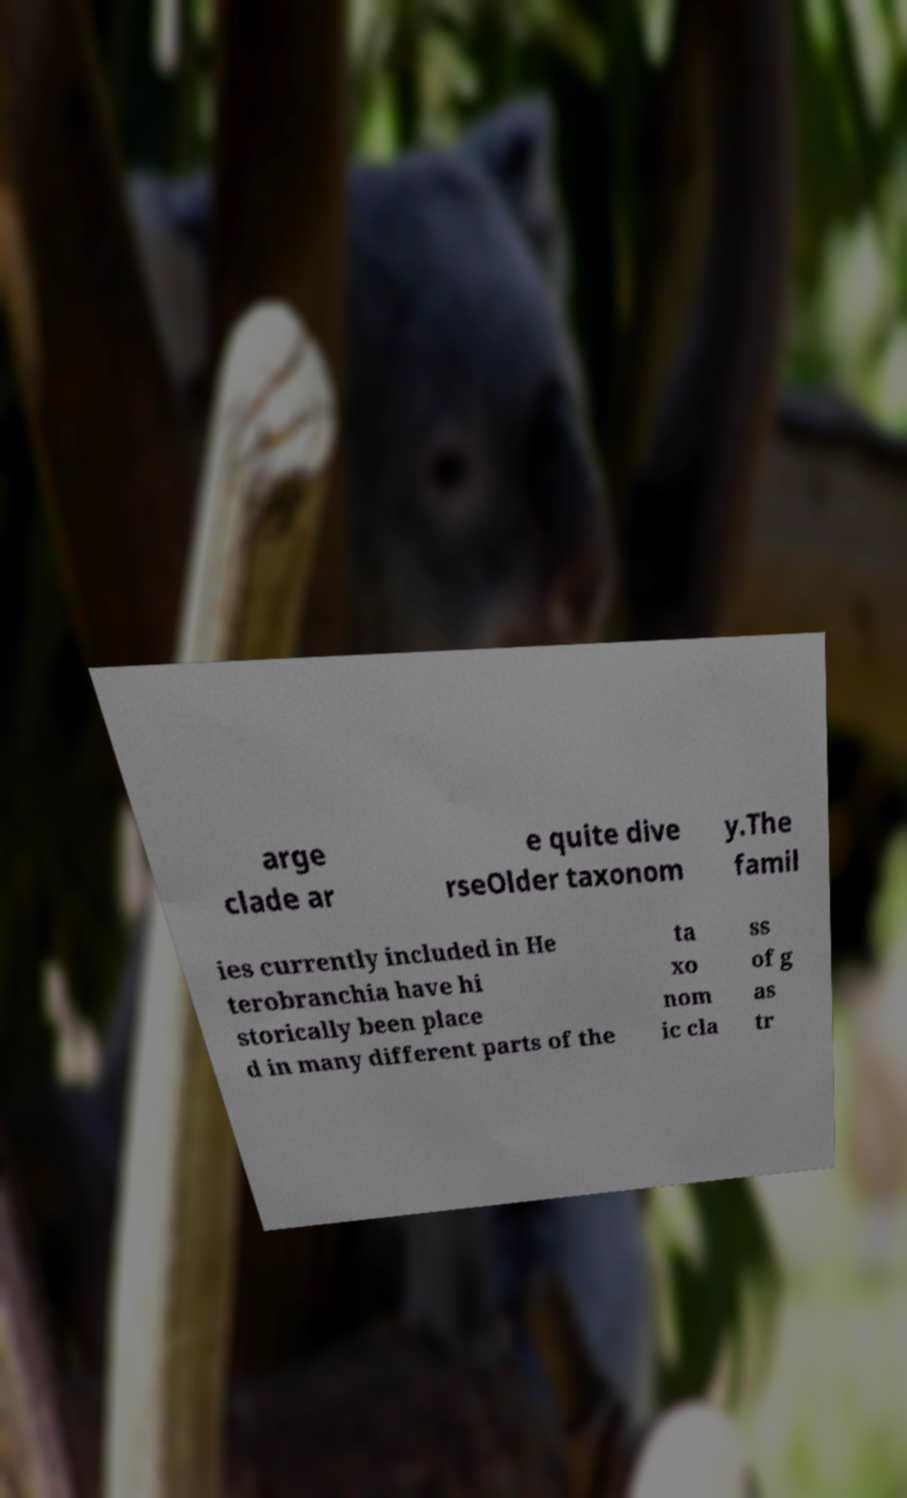There's text embedded in this image that I need extracted. Can you transcribe it verbatim? arge clade ar e quite dive rseOlder taxonom y.The famil ies currently included in He terobranchia have hi storically been place d in many different parts of the ta xo nom ic cla ss of g as tr 